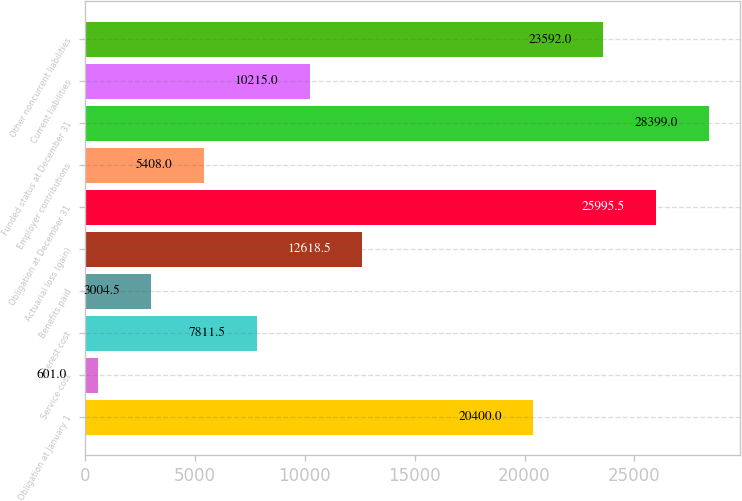Convert chart to OTSL. <chart><loc_0><loc_0><loc_500><loc_500><bar_chart><fcel>Obligation at January 1<fcel>Service cost<fcel>Interest cost<fcel>Benefits paid<fcel>Actuarial loss (gain)<fcel>Obligation at December 31<fcel>Employer contributions<fcel>Funded status at December 31<fcel>Current liabilities<fcel>Other noncurrent liabilities<nl><fcel>20400<fcel>601<fcel>7811.5<fcel>3004.5<fcel>12618.5<fcel>25995.5<fcel>5408<fcel>28399<fcel>10215<fcel>23592<nl></chart> 